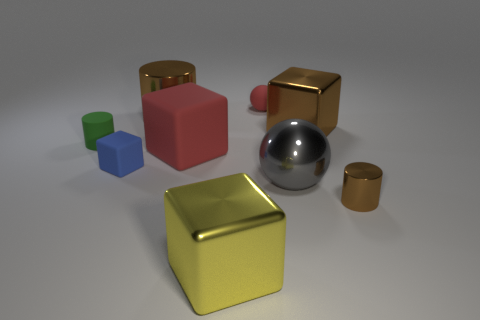Subtract 1 blocks. How many blocks are left? 3 Subtract all balls. How many objects are left? 7 Add 4 matte things. How many matte things exist? 8 Subtract 0 purple cylinders. How many objects are left? 9 Subtract all large yellow blocks. Subtract all small brown objects. How many objects are left? 7 Add 1 brown objects. How many brown objects are left? 4 